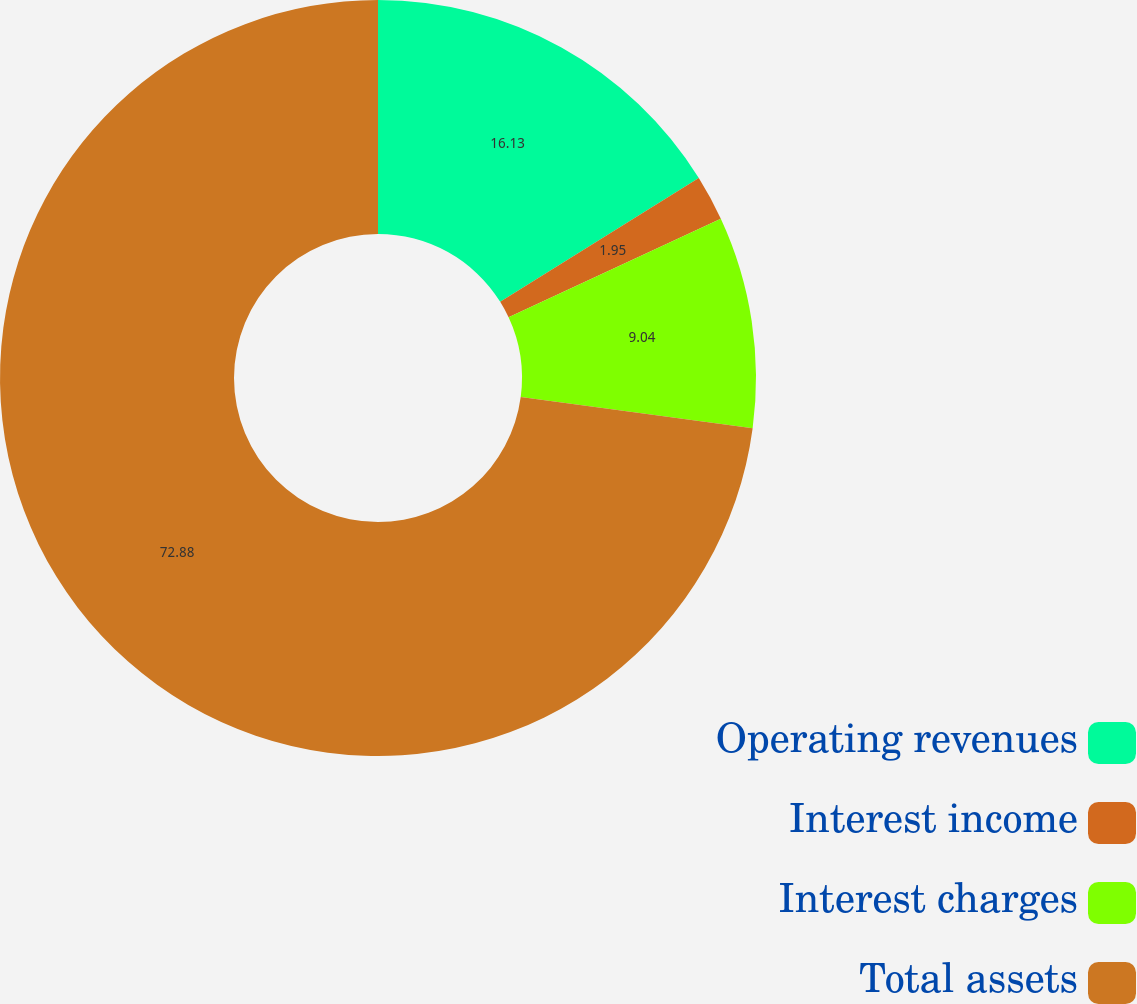Convert chart to OTSL. <chart><loc_0><loc_0><loc_500><loc_500><pie_chart><fcel>Operating revenues<fcel>Interest income<fcel>Interest charges<fcel>Total assets<nl><fcel>16.13%<fcel>1.95%<fcel>9.04%<fcel>72.88%<nl></chart> 